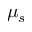<formula> <loc_0><loc_0><loc_500><loc_500>\mu _ { s }</formula> 